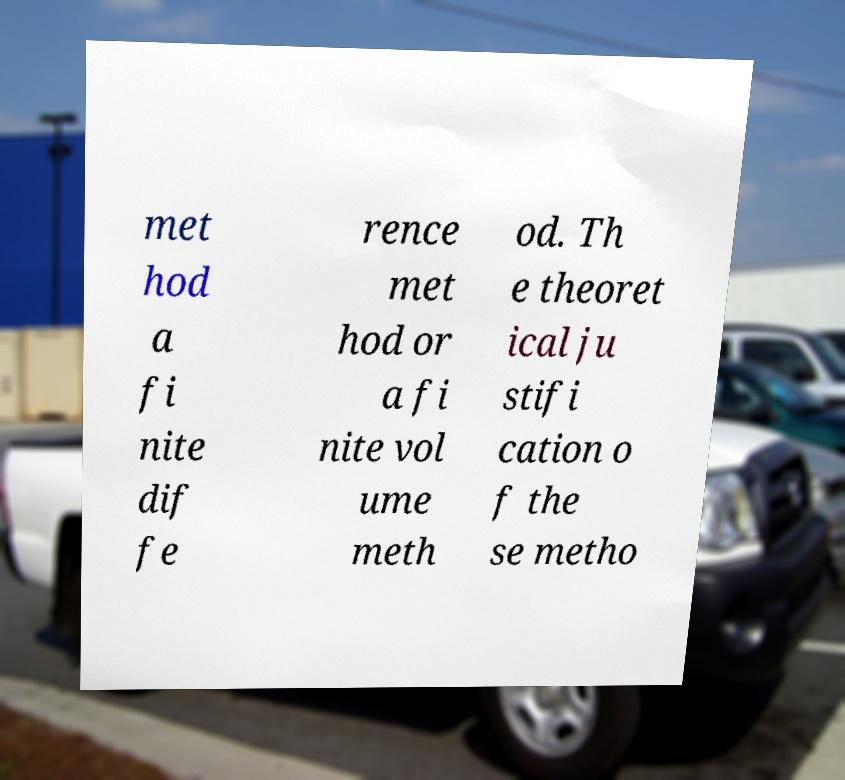What messages or text are displayed in this image? I need them in a readable, typed format. met hod a fi nite dif fe rence met hod or a fi nite vol ume meth od. Th e theoret ical ju stifi cation o f the se metho 